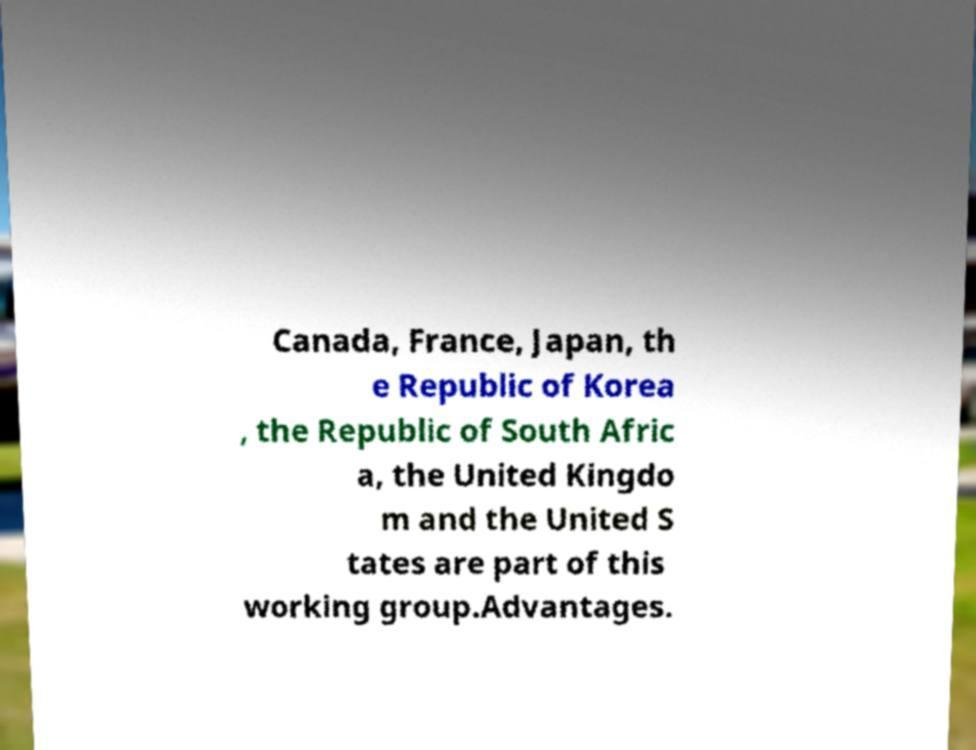Please identify and transcribe the text found in this image. Canada, France, Japan, th e Republic of Korea , the Republic of South Afric a, the United Kingdo m and the United S tates are part of this working group.Advantages. 